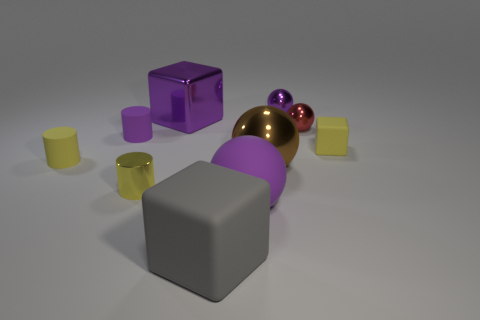What number of small objects are rubber objects or brown shiny objects?
Make the answer very short. 3. The other large matte object that is the same shape as the red object is what color?
Your response must be concise. Purple. Is the size of the purple metal ball the same as the purple rubber cylinder?
Give a very brief answer. Yes. What number of things are yellow cylinders or tiny metal balls to the left of the tiny red sphere?
Provide a succinct answer. 3. What is the color of the rubber cube that is in front of the small thing in front of the large shiny sphere?
Ensure brevity in your answer.  Gray. Do the cylinder in front of the brown metallic sphere and the small cube have the same color?
Your response must be concise. Yes. What is the material of the big purple object that is in front of the small yellow cube?
Offer a very short reply. Rubber. The metallic cylinder has what size?
Your answer should be very brief. Small. Are the yellow thing right of the yellow shiny cylinder and the big gray thing made of the same material?
Your response must be concise. Yes. What number of red spheres are there?
Give a very brief answer. 1. 